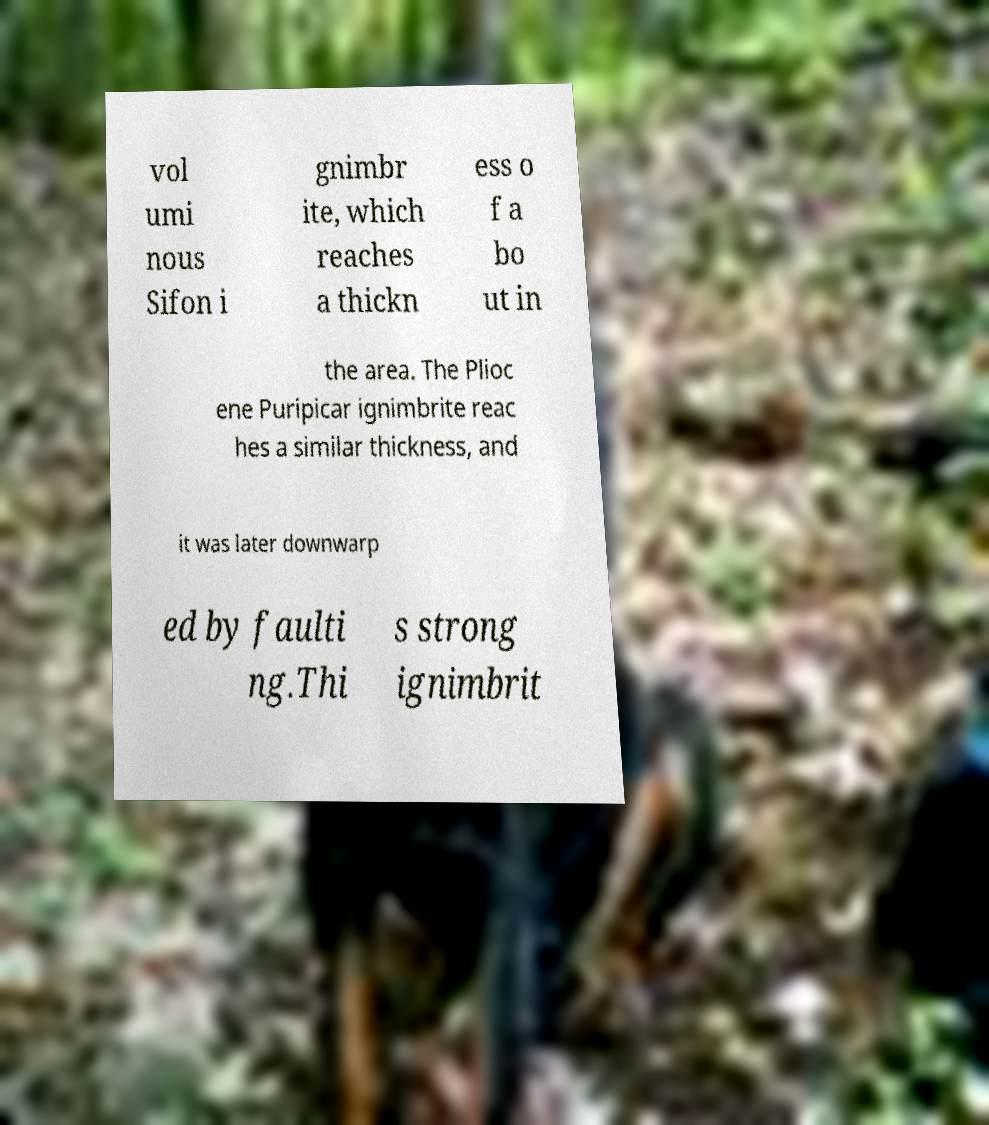There's text embedded in this image that I need extracted. Can you transcribe it verbatim? vol umi nous Sifon i gnimbr ite, which reaches a thickn ess o f a bo ut in the area. The Plioc ene Puripicar ignimbrite reac hes a similar thickness, and it was later downwarp ed by faulti ng.Thi s strong ignimbrit 